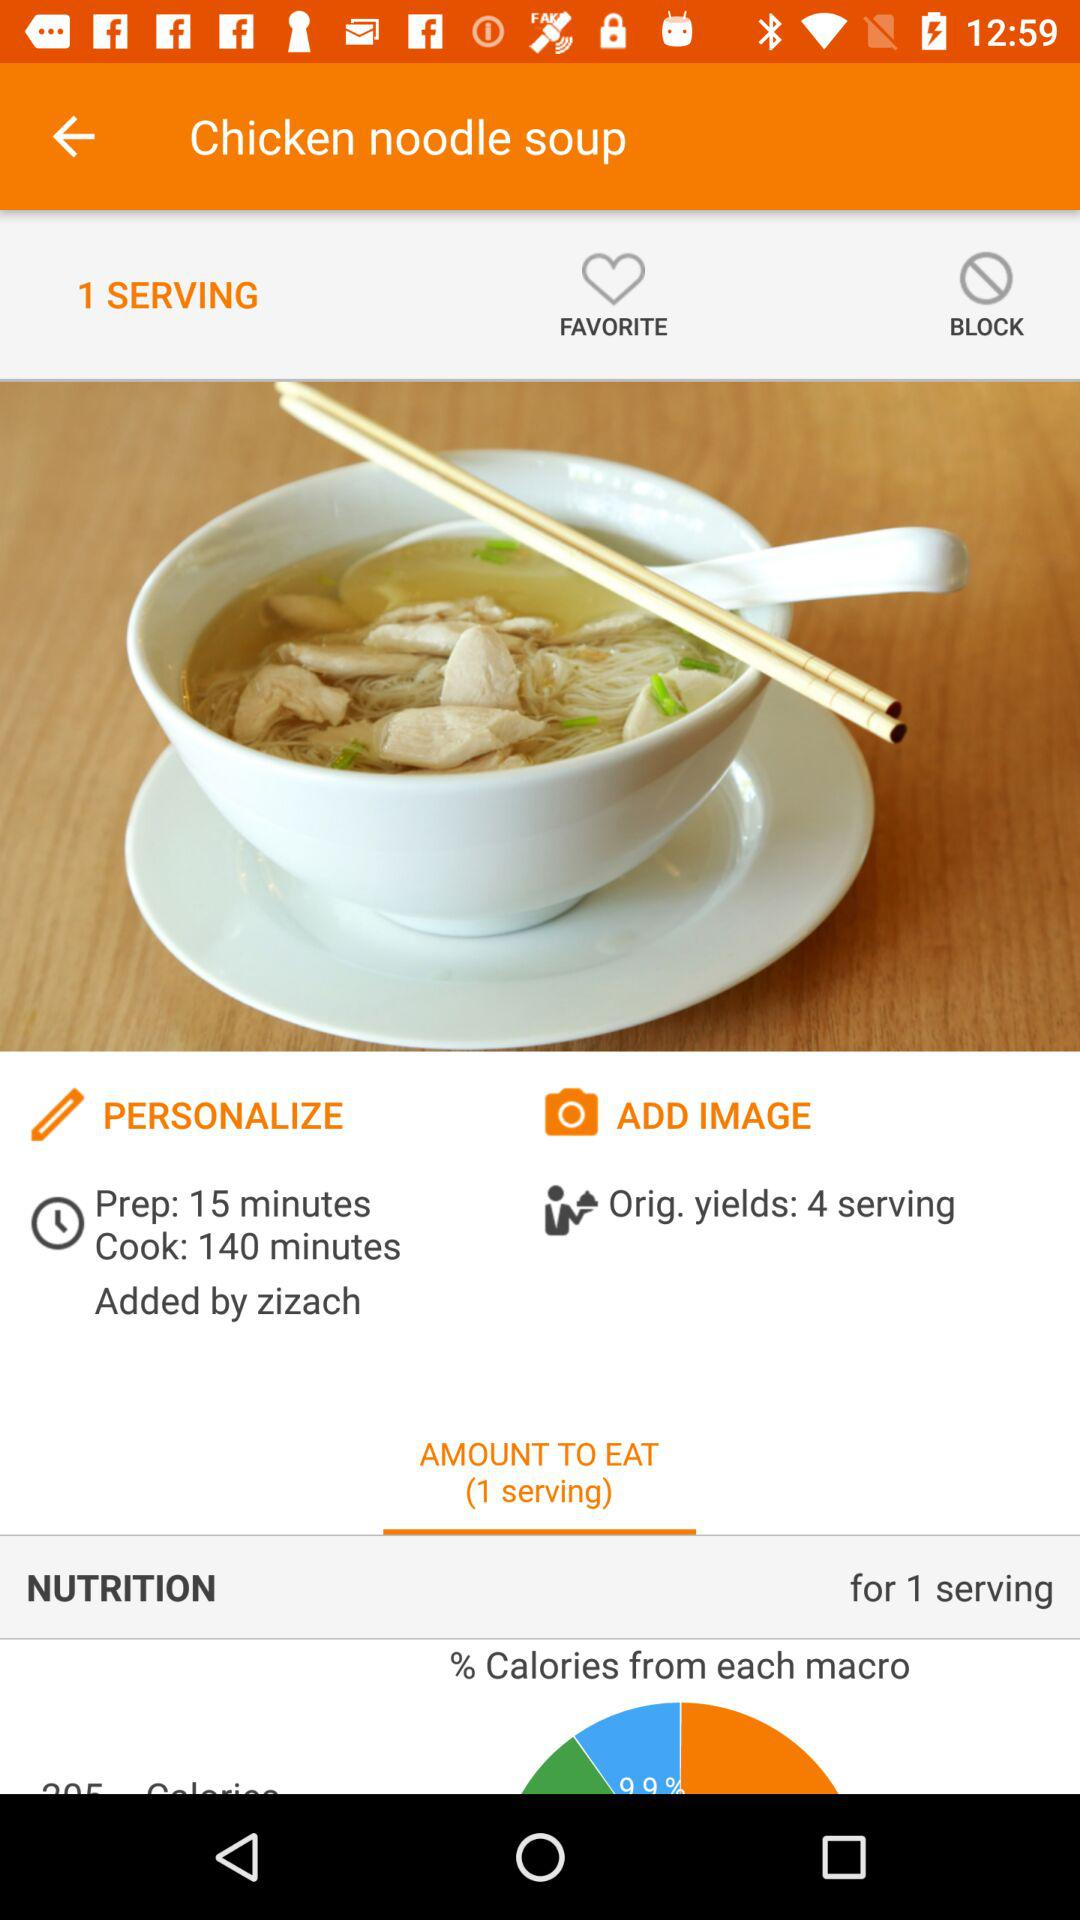How many servings does the original recipe make?
Answer the question using a single word or phrase. 4 